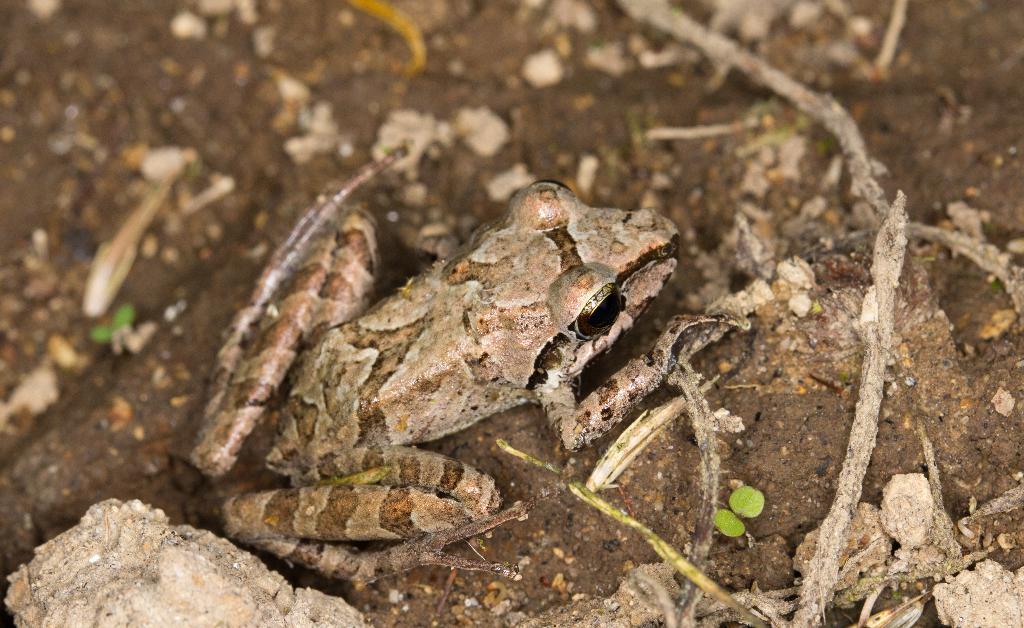Describe this image in one or two sentences. In this image we can see a frog on the ground. 